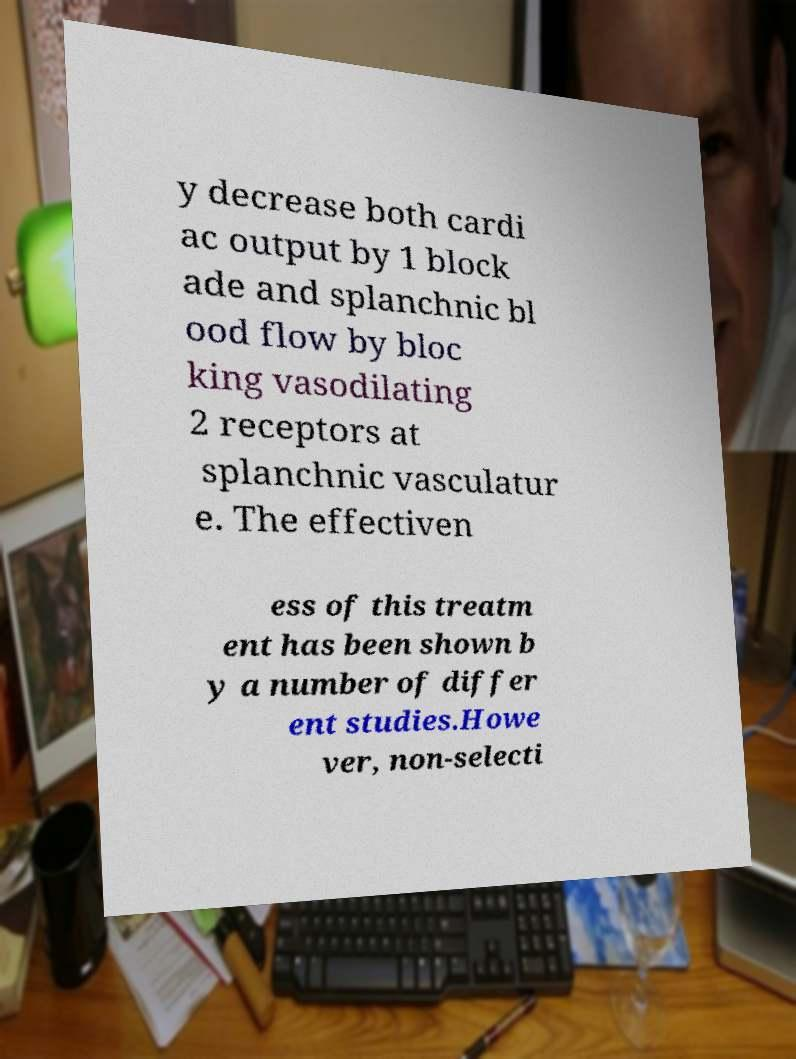Could you extract and type out the text from this image? y decrease both cardi ac output by 1 block ade and splanchnic bl ood flow by bloc king vasodilating 2 receptors at splanchnic vasculatur e. The effectiven ess of this treatm ent has been shown b y a number of differ ent studies.Howe ver, non-selecti 